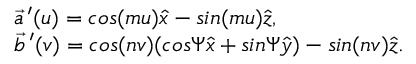Convert formula to latex. <formula><loc_0><loc_0><loc_500><loc_500>\begin{array} { l } { { \vec { a } \, ^ { \prime } ( u ) = \cos ( m u ) \hat { x } - \sin ( m u ) \hat { z } , } } \\ { { \vec { b } \, ^ { \prime } ( v ) = \cos ( n v ) ( \cos \Psi \hat { x } + \sin \Psi \hat { y } ) - \sin ( n v ) \hat { z } . } } \end{array}</formula> 